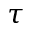Convert formula to latex. <formula><loc_0><loc_0><loc_500><loc_500>\tau</formula> 